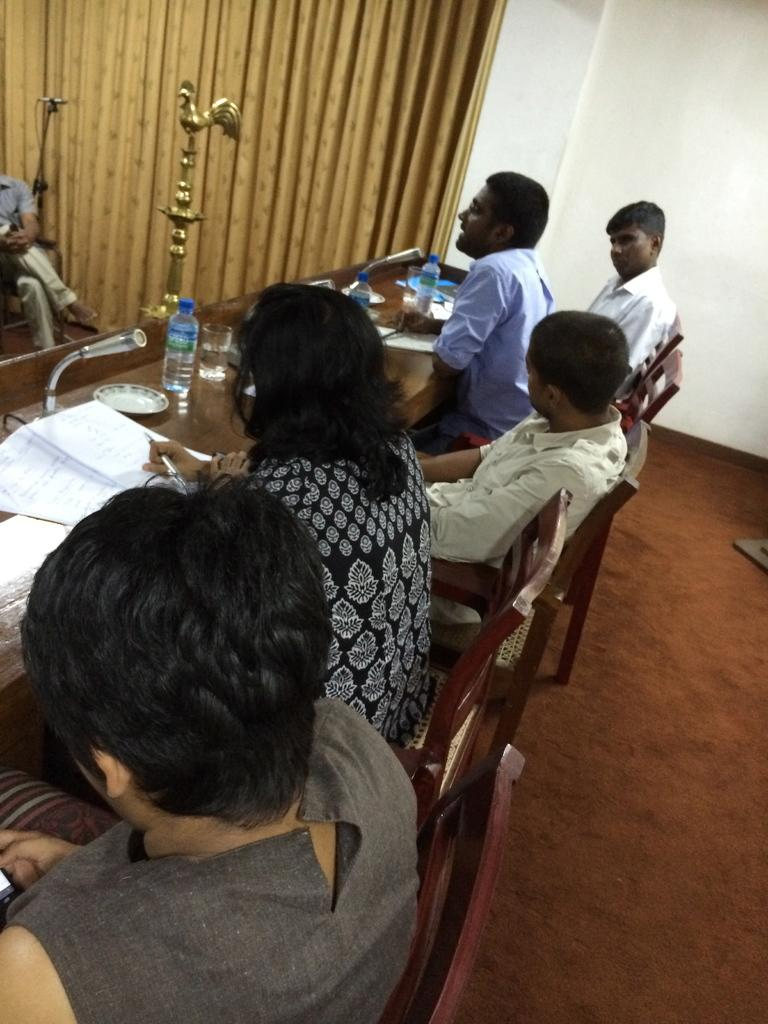What are the people in the image doing? The people in the image are sitting on chairs. What is on the table in front of the people? There are papers on a table in the image. Where is the table located in relation to the people? The table is in front of the people. How many oranges are on the table in the image? There are no oranges present in the image. What type of nose can be seen on the secretary in the image? There is no secretary present in the image, and therefore no nose to describe. 